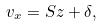<formula> <loc_0><loc_0><loc_500><loc_500>v _ { x } = S z + \delta ,</formula> 